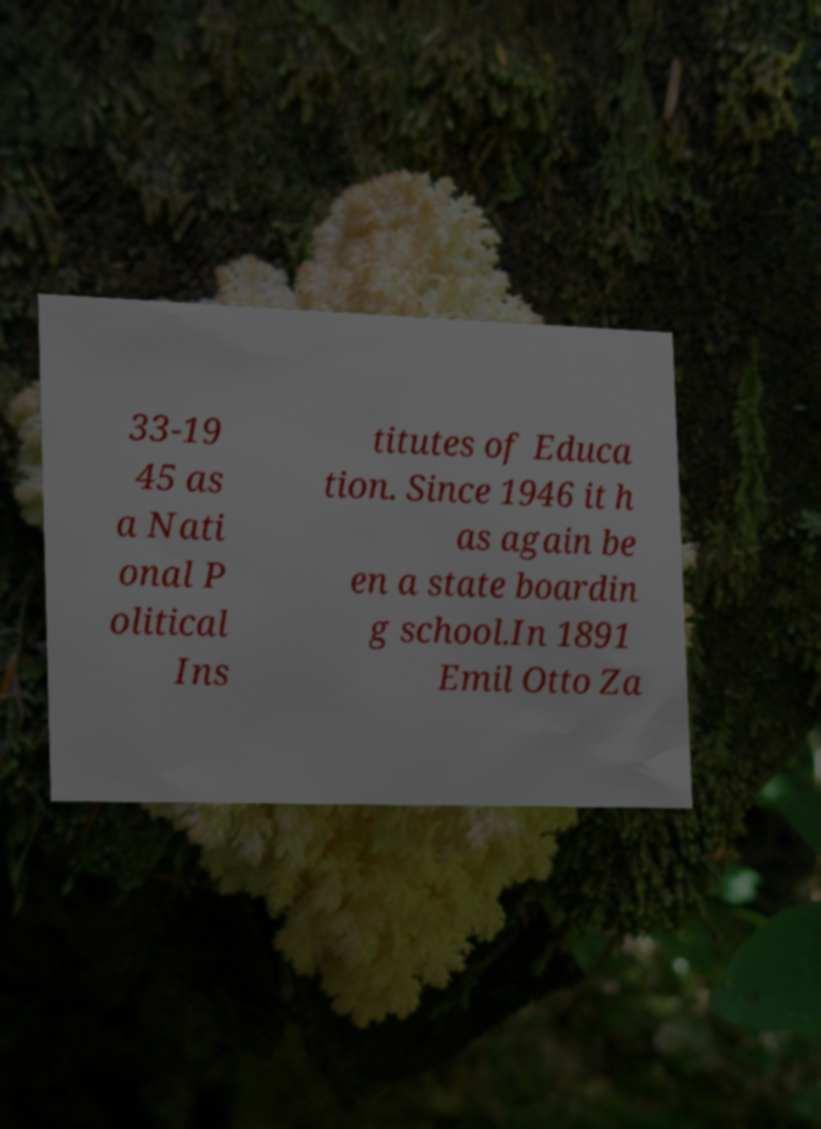Can you read and provide the text displayed in the image?This photo seems to have some interesting text. Can you extract and type it out for me? 33-19 45 as a Nati onal P olitical Ins titutes of Educa tion. Since 1946 it h as again be en a state boardin g school.In 1891 Emil Otto Za 